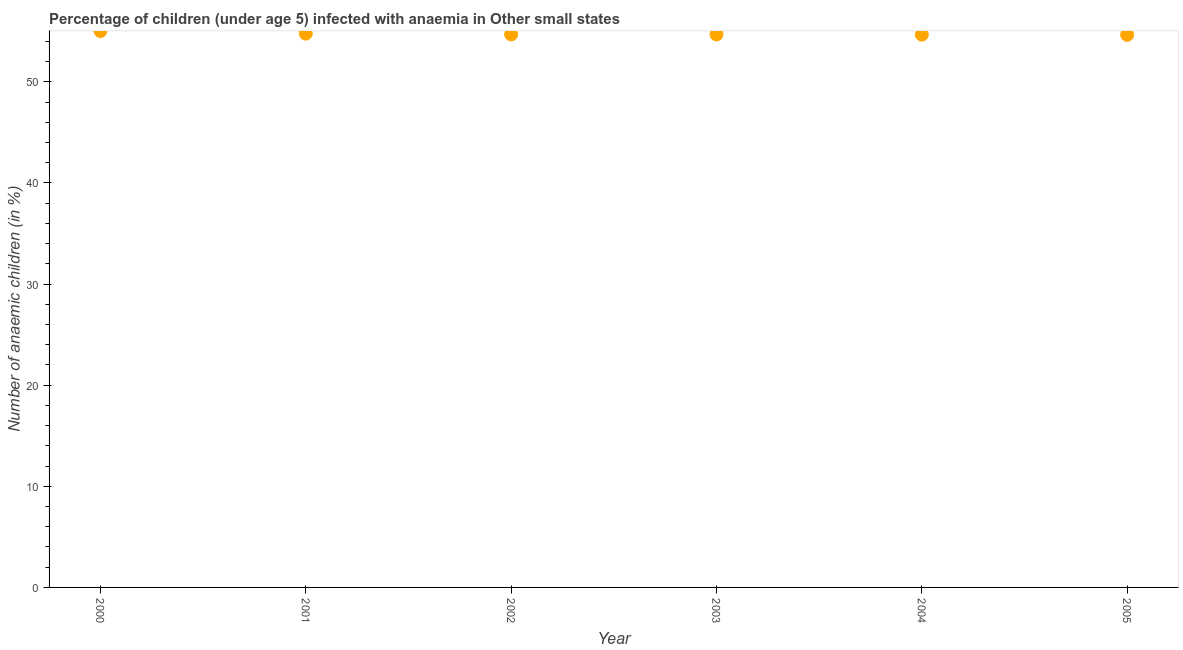What is the number of anaemic children in 2005?
Provide a succinct answer. 54.64. Across all years, what is the maximum number of anaemic children?
Provide a short and direct response. 55.02. Across all years, what is the minimum number of anaemic children?
Your answer should be compact. 54.64. In which year was the number of anaemic children maximum?
Give a very brief answer. 2000. In which year was the number of anaemic children minimum?
Offer a very short reply. 2005. What is the sum of the number of anaemic children?
Your answer should be compact. 328.45. What is the difference between the number of anaemic children in 2002 and 2005?
Make the answer very short. 0.04. What is the average number of anaemic children per year?
Provide a succinct answer. 54.74. What is the median number of anaemic children?
Keep it short and to the point. 54.68. What is the ratio of the number of anaemic children in 2000 to that in 2002?
Give a very brief answer. 1.01. What is the difference between the highest and the second highest number of anaemic children?
Ensure brevity in your answer.  0.26. Is the sum of the number of anaemic children in 2004 and 2005 greater than the maximum number of anaemic children across all years?
Offer a very short reply. Yes. What is the difference between the highest and the lowest number of anaemic children?
Your response must be concise. 0.38. In how many years, is the number of anaemic children greater than the average number of anaemic children taken over all years?
Offer a terse response. 2. How many dotlines are there?
Your response must be concise. 1. How many years are there in the graph?
Provide a succinct answer. 6. Does the graph contain any zero values?
Give a very brief answer. No. What is the title of the graph?
Make the answer very short. Percentage of children (under age 5) infected with anaemia in Other small states. What is the label or title of the X-axis?
Offer a terse response. Year. What is the label or title of the Y-axis?
Your answer should be very brief. Number of anaemic children (in %). What is the Number of anaemic children (in %) in 2000?
Ensure brevity in your answer.  55.02. What is the Number of anaemic children (in %) in 2001?
Give a very brief answer. 54.76. What is the Number of anaemic children (in %) in 2002?
Your answer should be compact. 54.68. What is the Number of anaemic children (in %) in 2003?
Your answer should be compact. 54.68. What is the Number of anaemic children (in %) in 2004?
Offer a very short reply. 54.66. What is the Number of anaemic children (in %) in 2005?
Make the answer very short. 54.64. What is the difference between the Number of anaemic children (in %) in 2000 and 2001?
Make the answer very short. 0.26. What is the difference between the Number of anaemic children (in %) in 2000 and 2002?
Offer a very short reply. 0.34. What is the difference between the Number of anaemic children (in %) in 2000 and 2003?
Ensure brevity in your answer.  0.34. What is the difference between the Number of anaemic children (in %) in 2000 and 2004?
Provide a short and direct response. 0.36. What is the difference between the Number of anaemic children (in %) in 2000 and 2005?
Your answer should be compact. 0.38. What is the difference between the Number of anaemic children (in %) in 2001 and 2002?
Offer a terse response. 0.08. What is the difference between the Number of anaemic children (in %) in 2001 and 2003?
Give a very brief answer. 0.08. What is the difference between the Number of anaemic children (in %) in 2001 and 2004?
Your response must be concise. 0.1. What is the difference between the Number of anaemic children (in %) in 2001 and 2005?
Keep it short and to the point. 0.12. What is the difference between the Number of anaemic children (in %) in 2002 and 2003?
Keep it short and to the point. 0. What is the difference between the Number of anaemic children (in %) in 2002 and 2004?
Provide a short and direct response. 0.02. What is the difference between the Number of anaemic children (in %) in 2002 and 2005?
Give a very brief answer. 0.04. What is the difference between the Number of anaemic children (in %) in 2003 and 2004?
Offer a very short reply. 0.02. What is the difference between the Number of anaemic children (in %) in 2003 and 2005?
Offer a very short reply. 0.04. What is the difference between the Number of anaemic children (in %) in 2004 and 2005?
Make the answer very short. 0.02. What is the ratio of the Number of anaemic children (in %) in 2000 to that in 2001?
Provide a succinct answer. 1. What is the ratio of the Number of anaemic children (in %) in 2000 to that in 2003?
Your answer should be compact. 1.01. What is the ratio of the Number of anaemic children (in %) in 2001 to that in 2005?
Your answer should be very brief. 1. What is the ratio of the Number of anaemic children (in %) in 2002 to that in 2003?
Your answer should be very brief. 1. What is the ratio of the Number of anaemic children (in %) in 2002 to that in 2005?
Provide a short and direct response. 1. What is the ratio of the Number of anaemic children (in %) in 2003 to that in 2004?
Keep it short and to the point. 1. 